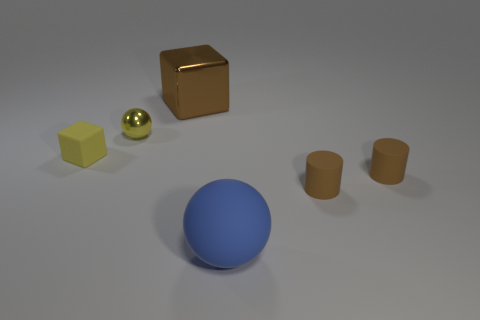Can you describe the lighting and shadow effects in this scene? The scene is illuminated from above, casting soft shadows directly beneath the objects. The lighting is not overly harsh, as indicated by the gradual transitions in the shadows' edges. This softer light lends a calm and controlled atmosphere to the scene, highlighting the objects' textures and shapes without causing sharp contrasts or glare.  Does the lighting affect the perception of the objects' colors? Yes, the lighting can influence how we perceive the colors of these objects. Even, soft illumination generally allows for truer color representation by reducing glare and high contrast, which can distort color perception. Here, the light accentuates the objects' intrinsic colors, such as the deep blue of the sphere and the shininess of the small yellow ball. 